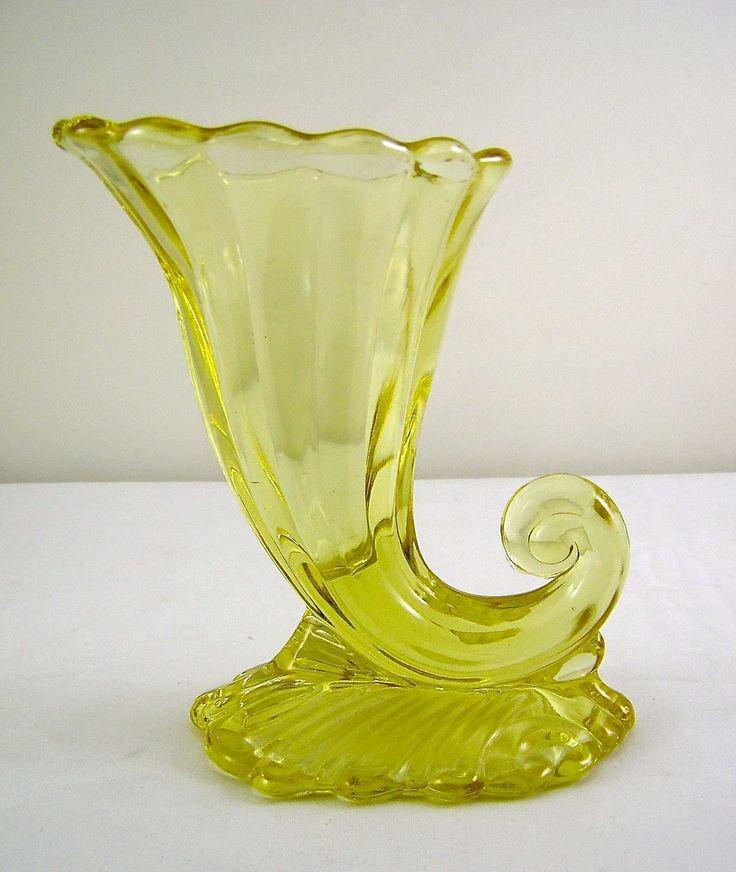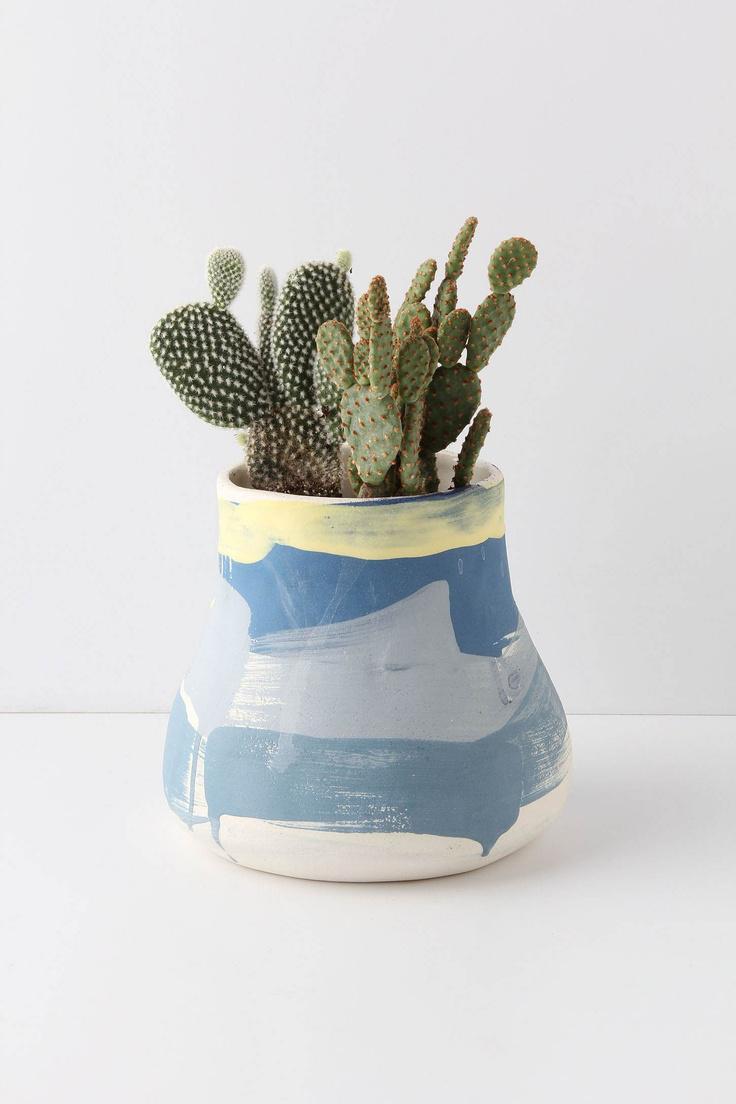The first image is the image on the left, the second image is the image on the right. Considering the images on both sides, is "The right image contains two glass sculptures." valid? Answer yes or no. No. The first image is the image on the left, the second image is the image on the right. Analyze the images presented: Is the assertion "The left image shows one vase that tapers to a wave-curl at its bottom, and the right image shows at least one vase with a rounded bottom and no curl." valid? Answer yes or no. Yes. 